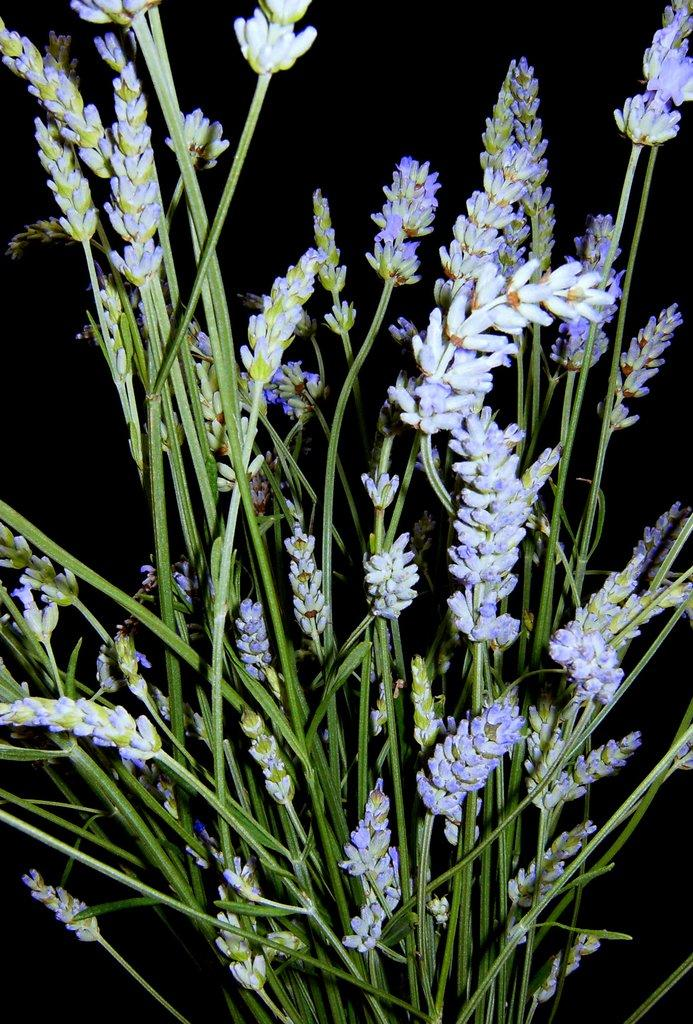What is present in the image? There is a plant in the image. What can be observed about the plant? The plant has flowers. What type of vase is the plant placed in within the image? There is no vase present in the image; the plant is not placed in a vase. What kind of shade is provided for the plant in the image? There is no shade visible in the image; the plant is exposed to the light. 